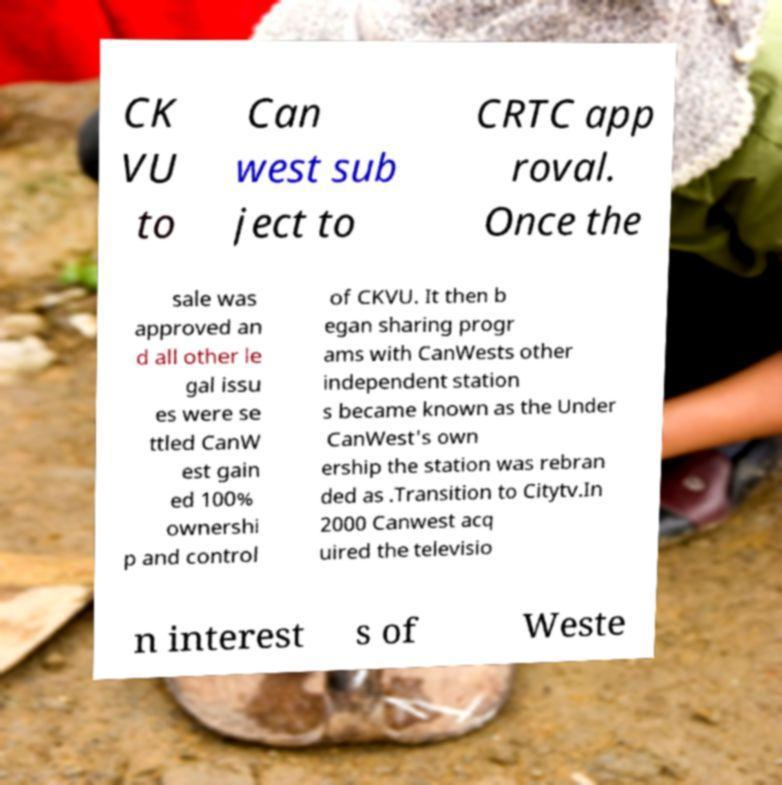I need the written content from this picture converted into text. Can you do that? CK VU to Can west sub ject to CRTC app roval. Once the sale was approved an d all other le gal issu es were se ttled CanW est gain ed 100% ownershi p and control of CKVU. It then b egan sharing progr ams with CanWests other independent station s became known as the Under CanWest's own ership the station was rebran ded as .Transition to Citytv.In 2000 Canwest acq uired the televisio n interest s of Weste 